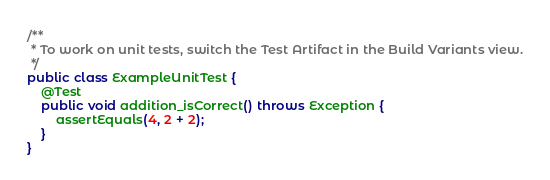<code> <loc_0><loc_0><loc_500><loc_500><_Java_>
/**
 * To work on unit tests, switch the Test Artifact in the Build Variants view.
 */
public class ExampleUnitTest {
    @Test
    public void addition_isCorrect() throws Exception {
        assertEquals(4, 2 + 2);
    }
}</code> 